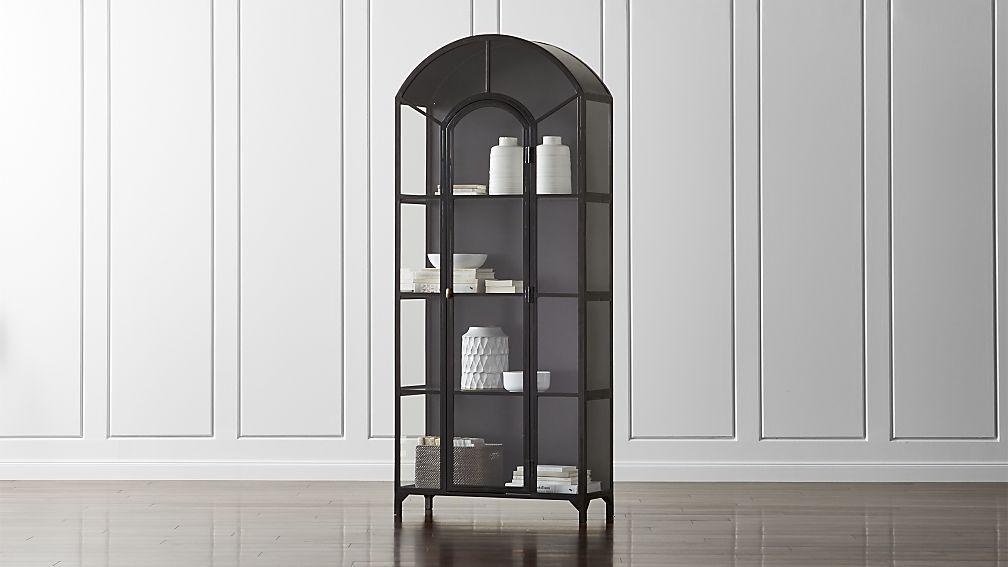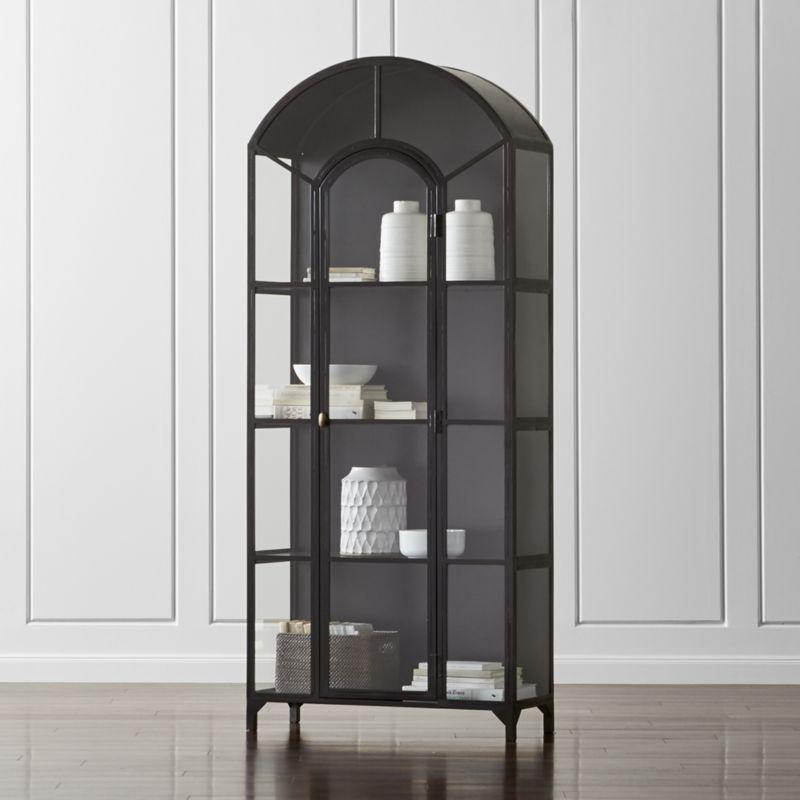The first image is the image on the left, the second image is the image on the right. For the images displayed, is the sentence "At least one bookcase has open shelves, no backboard to it." factually correct? Answer yes or no. No. 